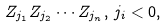<formula> <loc_0><loc_0><loc_500><loc_500>Z _ { j _ { 1 } } Z _ { j _ { 2 } } \cdots Z _ { j _ { n } } , \, j _ { i } < 0 ,</formula> 